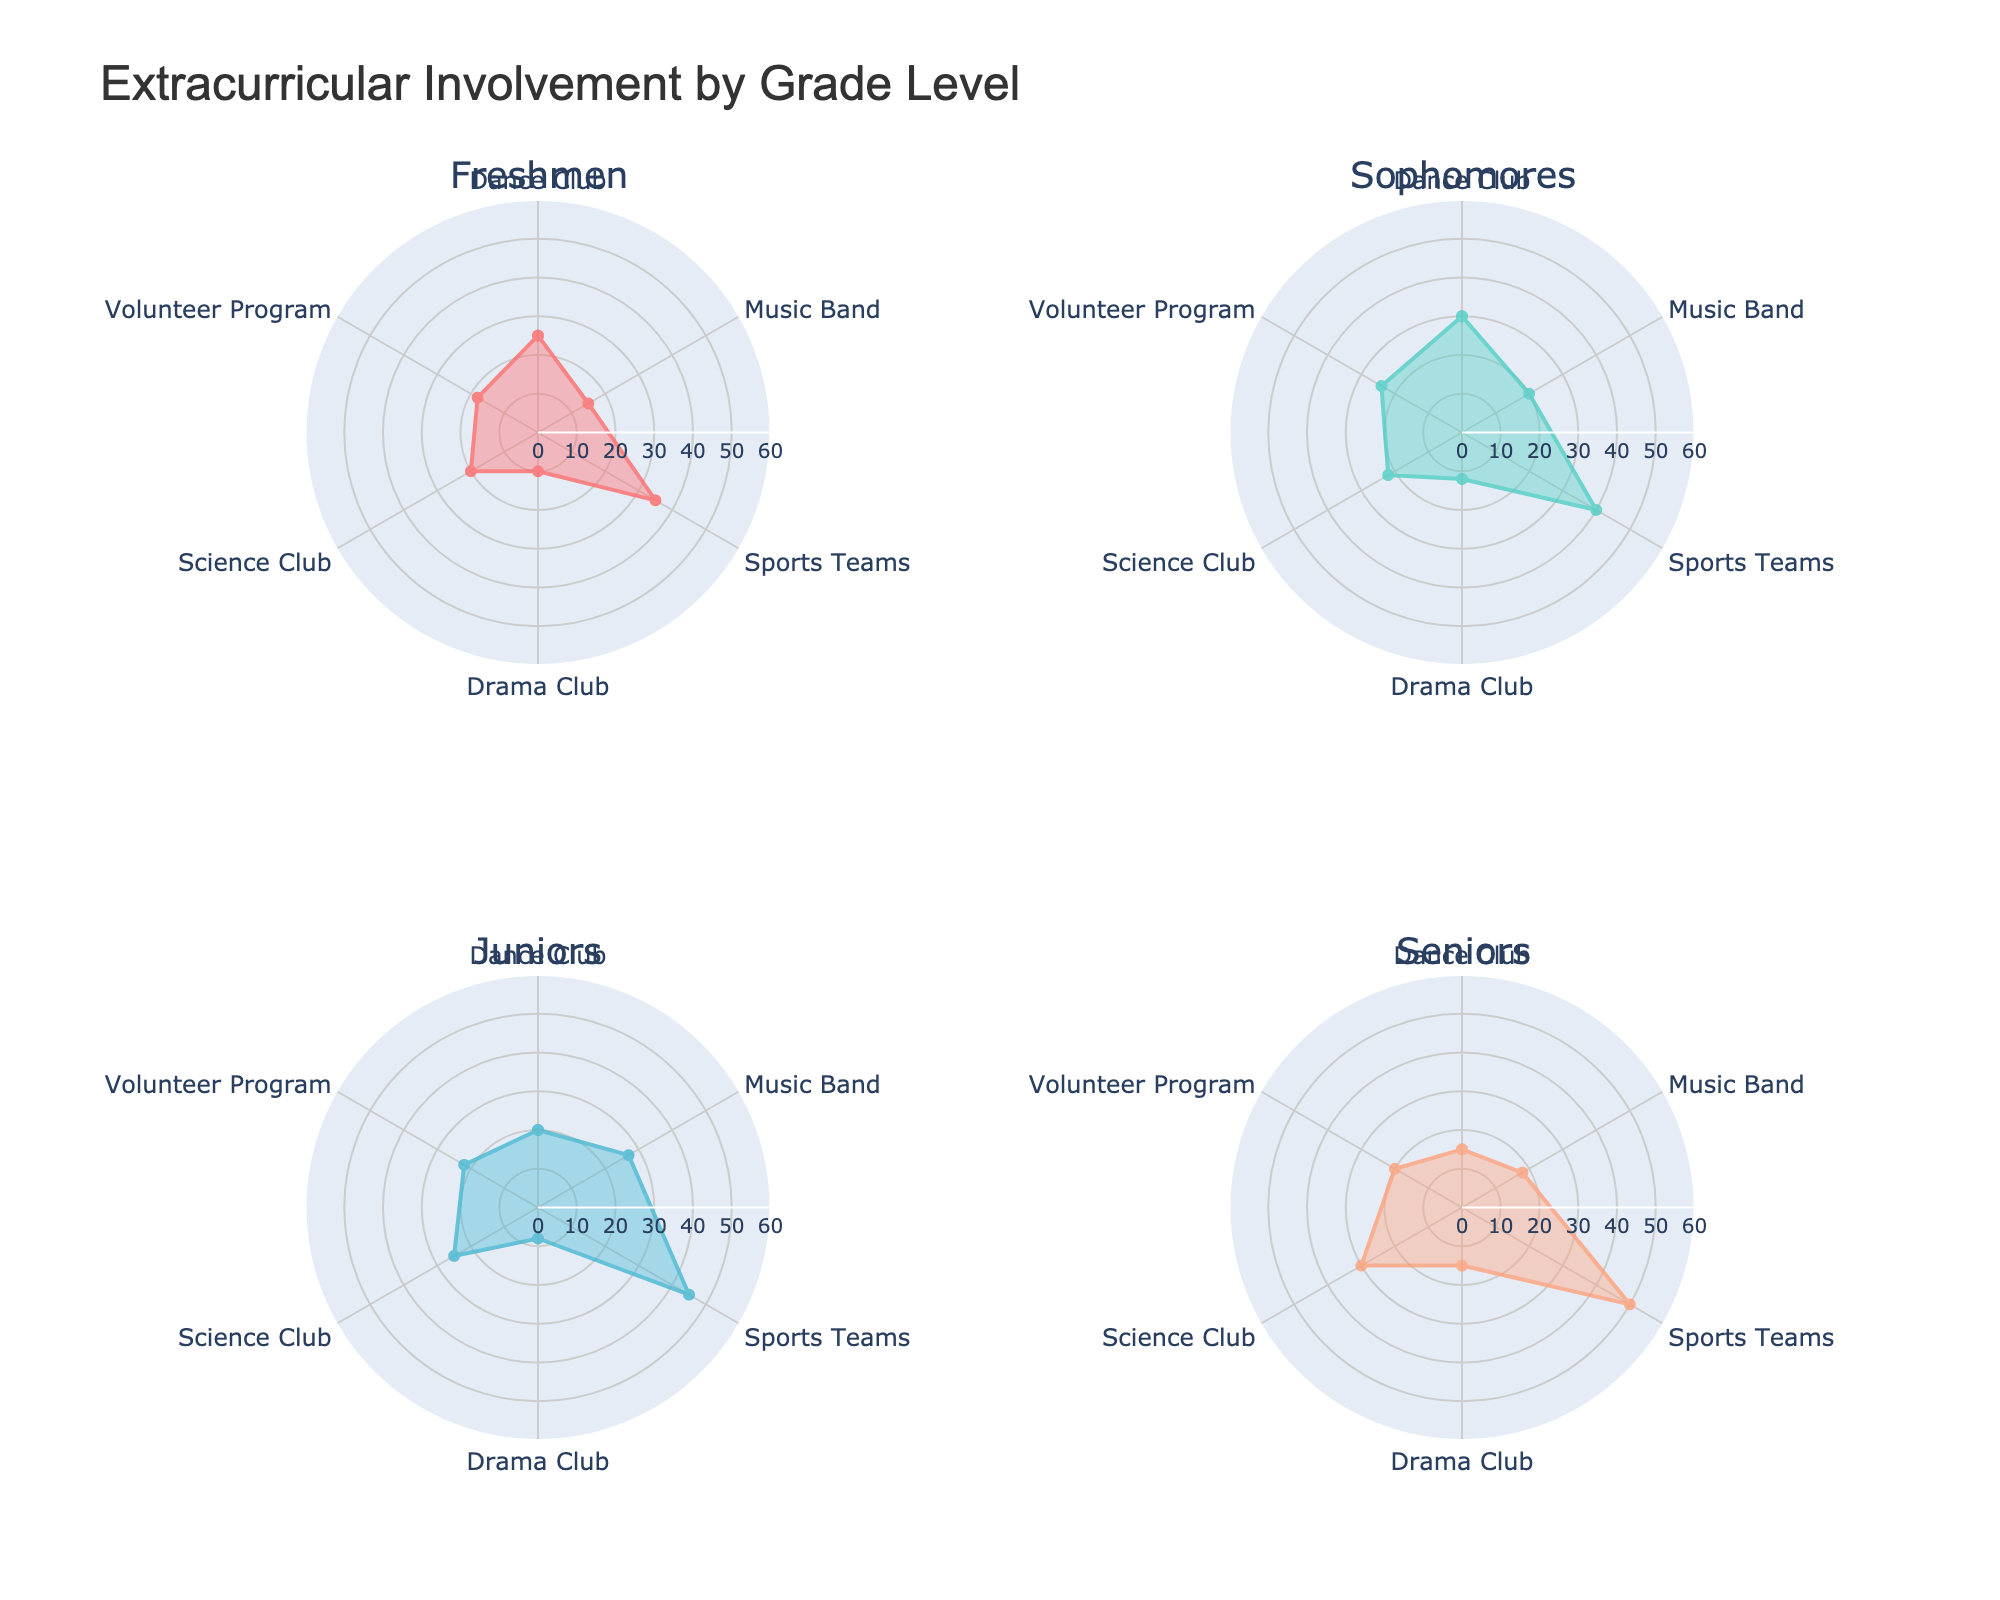What's the title of the figure? The figure shows a title at the top center.
Answer: Extracurricular Involvement by Grade Level What axis range is displayed for the radial axis? By examining the radial axis, you can see the range from 0 to 60.
Answer: 0 to 60 Which grade level has the highest participation in Sports Teams? Looking at the subplot for each grade level, the Sports Teams category has the highest value for Seniors.
Answer: Seniors How many activities have higher participation rates among Freshmen compared to Seniors? By comparing the values for Freshmen and Seniors in each activity, you'll find that Dance Club and Drama Club have higher participation rates for Freshmen.
Answer: 2 Which activity has the smallest range of participation rates across all grades? By calculating the difference between the highest and lowest participation rates for each activity, Drama Club has the smallest range.
Answer: Drama Club Which grade level has the most balanced participation across all activities? Balancing means having similar values across all activities. From the plots, Sophomores show the closest participation rates across different activities.
Answer: Sophomores What is the median participation rate for Juniors in all activities? Participation rates for Juniors are 20, 27, 45, 8, 25, 22. Sorting these values (8, 20, 22, 25, 27, 45), the median is the average of 22 and 25.
Answer: 23.5 How many activities see their highest participation rate among Freshmen? By examining each subplot, Drama Club is the only activity with the highest participation rate among Freshmen.
Answer: 1 What is the total participation rate in Clubs (Dance, Drama, Science) for Sophomores? Summing the rates: Dance (30) + Drama (12) + Science (22) = 64
Answer: 64 Which two grade levels have the most similar participation in Music Band? By comparing the Music Band participation rates, Freshmen (15) and Seniors (18) are the closest.
Answer: Freshmen and Seniors 